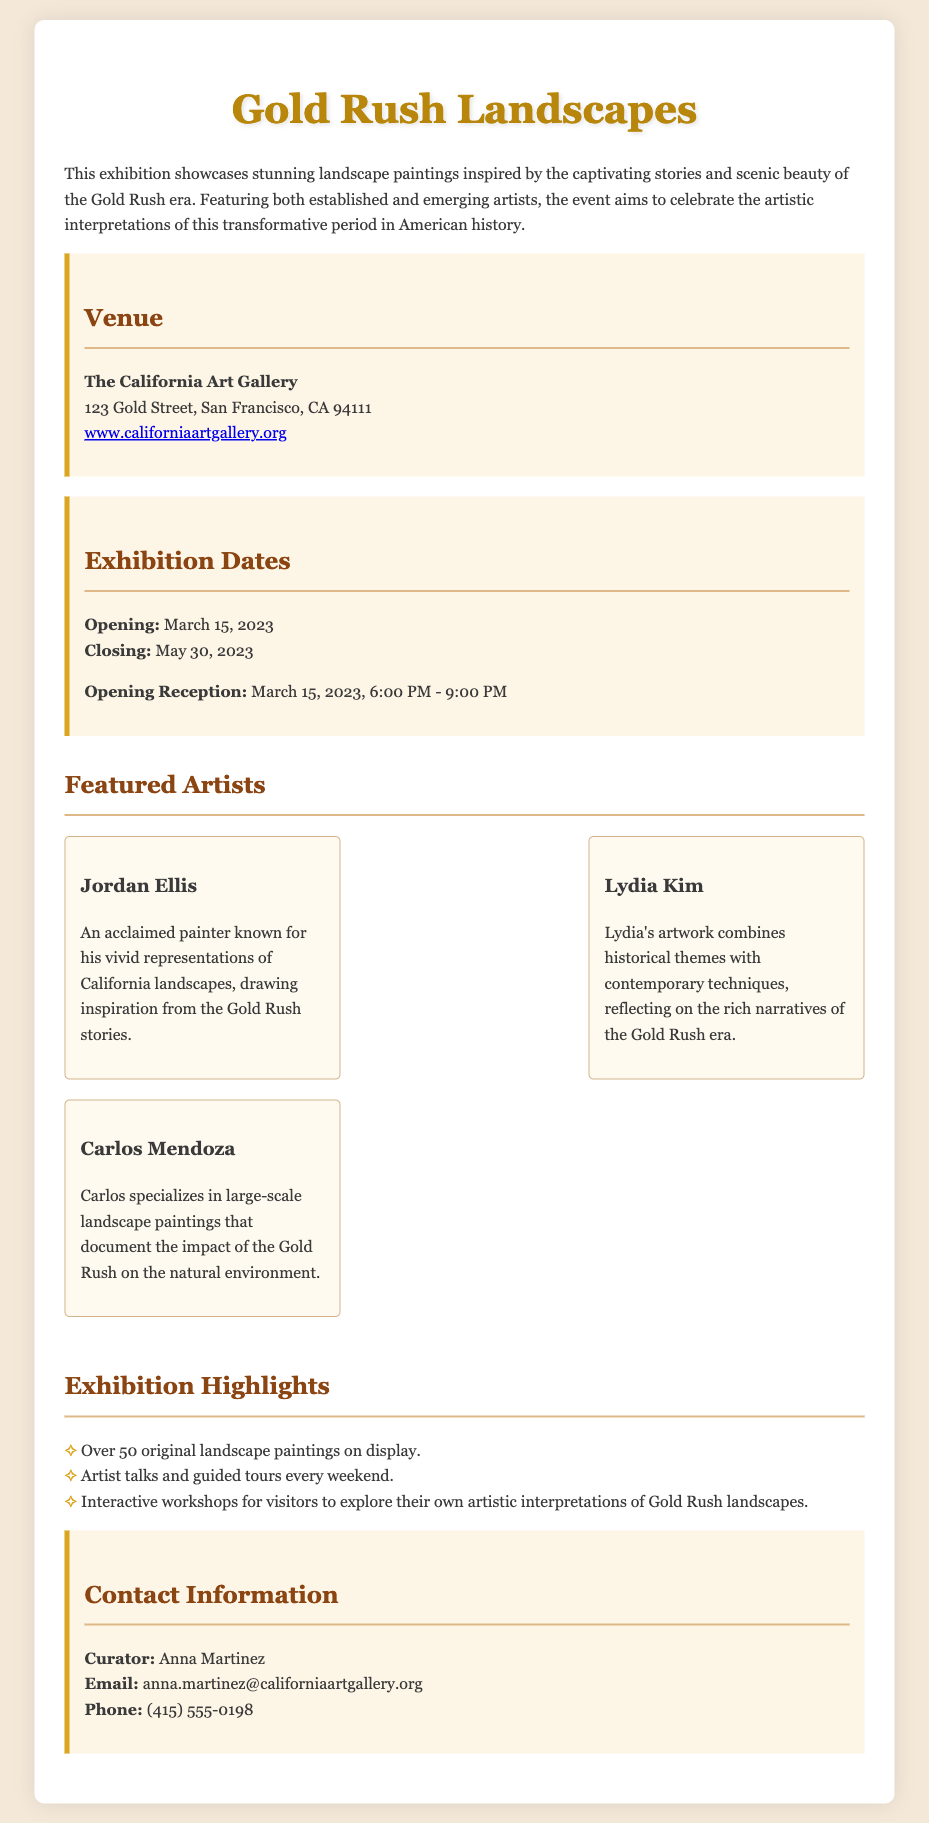What is the title of the exhibition? The title of the exhibition is provided at the top of the document, emphasizing the theme of the showcased art.
Answer: Gold Rush Landscapes Where is the exhibition being held? The venue of the exhibition is specified in a dedicated section of the document, including the address and a link.
Answer: The California Art Gallery When does the exhibition open? The opening date of the exhibition is highlighted in the dates section, which provides clear timelines.
Answer: March 15, 2023 Who is the curator of the exhibition? The document includes contact information and mentions the curator's name, which is relevant for inquiries.
Answer: Anna Martinez What type of workshops are mentioned in the highlights? The highlights section outlines the special activities available during the exhibition, indicating what visitors can participate in.
Answer: Interactive workshops How many original paintings will be on display? The number of original landscape paintings is explicitly stated in the exhibition highlights, which is a specific detail of interest.
Answer: Over 50 When is the opening reception? The opening reception time and date are distinctly listed under the exhibition dates, providing clear details for attendees.
Answer: March 15, 2023, 6:00 PM - 9:00 PM Which artist is known for representing California landscapes? The document provides brief descriptions of the featured artists, indicating their specialties and contributions.
Answer: Jordan Ellis What is the phone number for contact? The contact section provides detailed information, including a phone number for inquiries related to the exhibition.
Answer: (415) 555-0198 